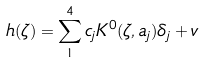Convert formula to latex. <formula><loc_0><loc_0><loc_500><loc_500>h ( \zeta ) = \sum _ { 1 } ^ { 4 } c _ { j } K ^ { 0 } ( \zeta , a _ { j } ) \delta _ { j } + v</formula> 